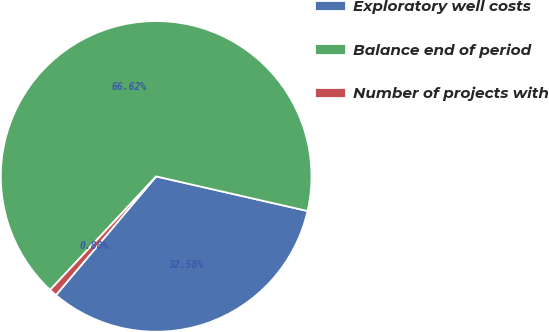Convert chart. <chart><loc_0><loc_0><loc_500><loc_500><pie_chart><fcel>Exploratory well costs<fcel>Balance end of period<fcel>Number of projects with<nl><fcel>32.58%<fcel>66.62%<fcel>0.8%<nl></chart> 